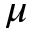<formula> <loc_0><loc_0><loc_500><loc_500>\mu</formula> 